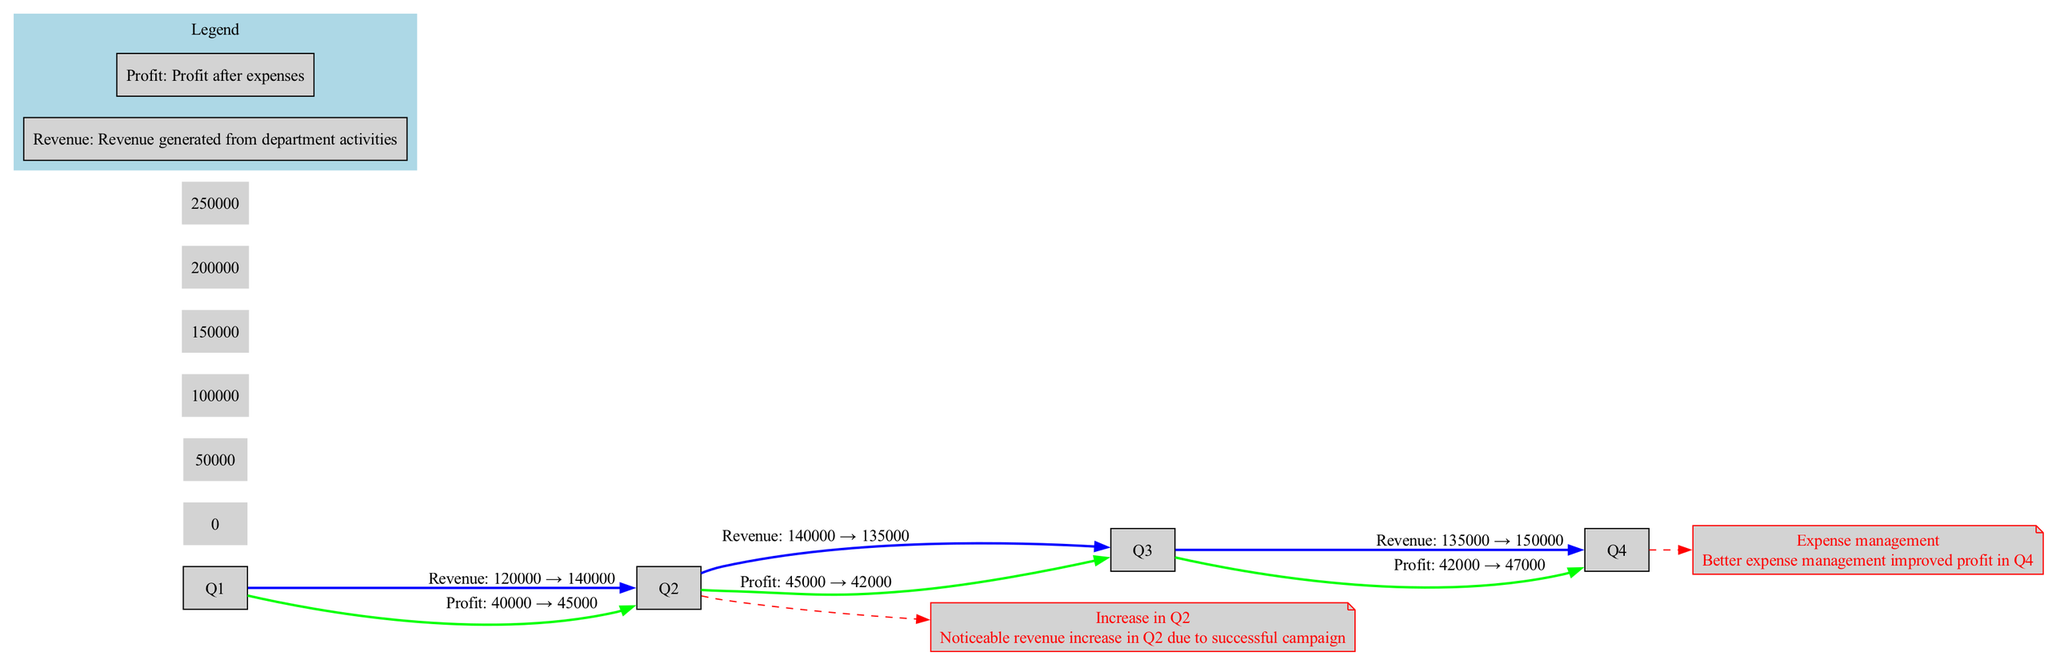What was the revenue in Q3? The diagram indicates that the revenue data for Q3 is 135000 USD as per the graph line for revenue.
Answer: 135000 USD What was the profit in Q4? By looking at the profit line in the diagram, we can see that the profit for Q4 is depicted as 47000 USD.
Answer: 47000 USD Which quarter had the highest revenue? Upon examining the revenue line, Q4 shows the highest revenue value at 150000 USD compared to the other quarters.
Answer: Q4 What was the noticeable trend in Q2? The annotation indicates a significant revenue increase in Q2 due to a successful campaign.
Answer: Revenue increase How did profit change from Q1 to Q2? The profit increased from 40000 in Q1 to 45000 in Q2, which indicates a growth in profit between these quarters.
Answer: Increased What is the total number of quarters represented in the diagram? The x-axis lists four quarters: Q1, Q2, Q3, Q4, thus totaling four distinct time periods.
Answer: 4 What was one reason for the improvement in profit for Q4? The annotations mention that better expense management contributed to the increase in profits noted for Q4.
Answer: Better expense management What color represents the profit line in the diagram? The profit line is represented by the color green according to the color coding provided in the diagram.
Answer: Green How does the revenue for Q2 compare to that of Q1? The revenue for Q2 (140000) is higher than that for Q1 (120000), showing an increase when comparing the two quarters.
Answer: Higher What is the maximum y-axis value shown on the diagram? The highest value listed on the y-axis is 250000 USD, which is the largest category shown on the scale.
Answer: 250000 USD 